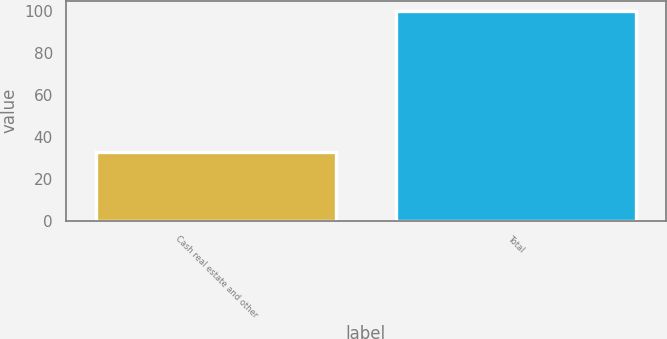Convert chart. <chart><loc_0><loc_0><loc_500><loc_500><bar_chart><fcel>Cash real estate and other<fcel>Total<nl><fcel>33<fcel>100<nl></chart> 